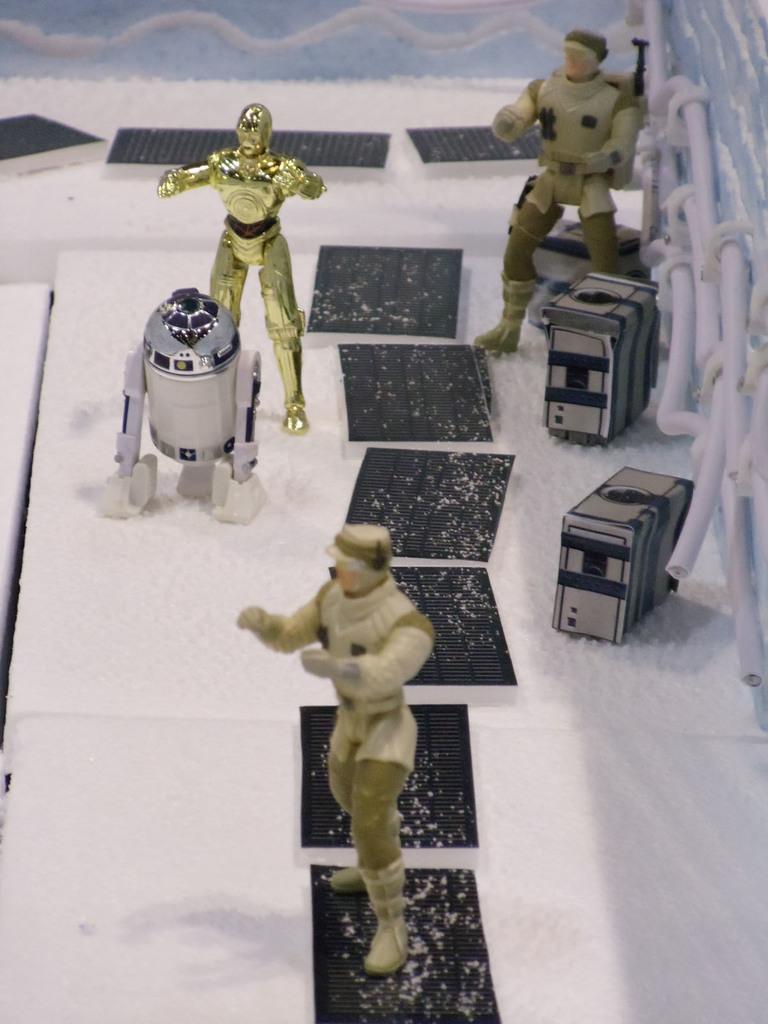Can you describe this image briefly? In this picture I can see toys, cables and some other objects. 